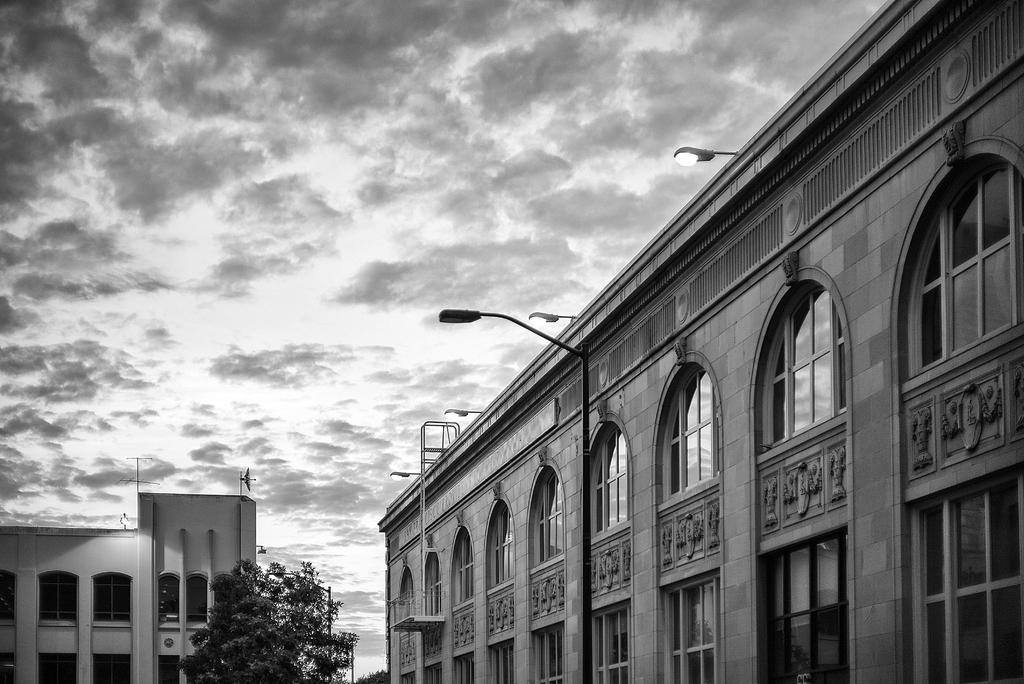Can you describe this image briefly? In the foreground of the picture we can see buildings, street lights and trees. At the top it is sky, sky is cloudy. 